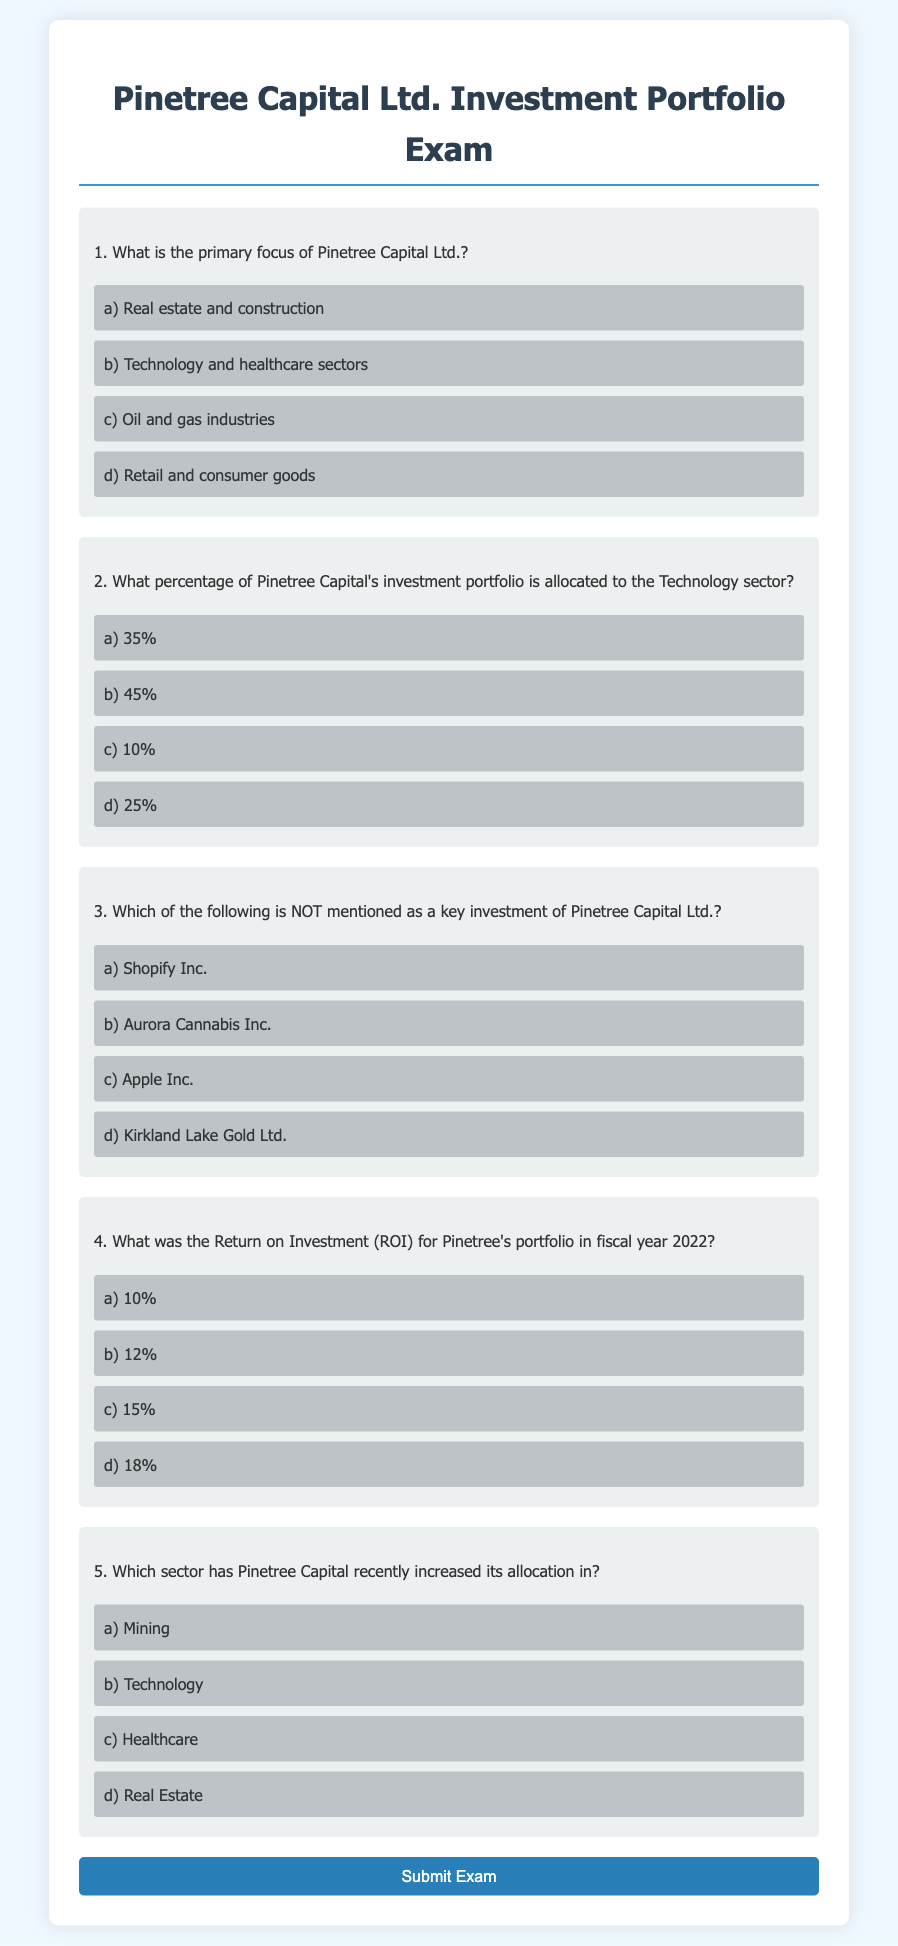What is the primary focus of Pinetree Capital Ltd.? The document provides four options regarding the primary focus of Pinetree Capital Ltd., highlighted in question 1.
Answer: Technology and healthcare sectors What percentage of Pinetree Capital's investment portfolio is allocated to the Technology sector? The answer to this question can be found in question 2 of the document, where the percentages are listed for selection.
Answer: 35% Which company is NOT mentioned as a key investment of Pinetree Capital Ltd.? This question asks for the company that is not listed among the options in question 3 of the document.
Answer: Apple Inc What was the Return on Investment (ROI) for Pinetree's portfolio in fiscal year 2022? The document specifies different ROI percentages in question 4, allowing for selection of the correct answer.
Answer: 12% Which sector has Pinetree Capital recently increased its allocation in? The document outlines options related to sector allocation in question 5.
Answer: Technology 